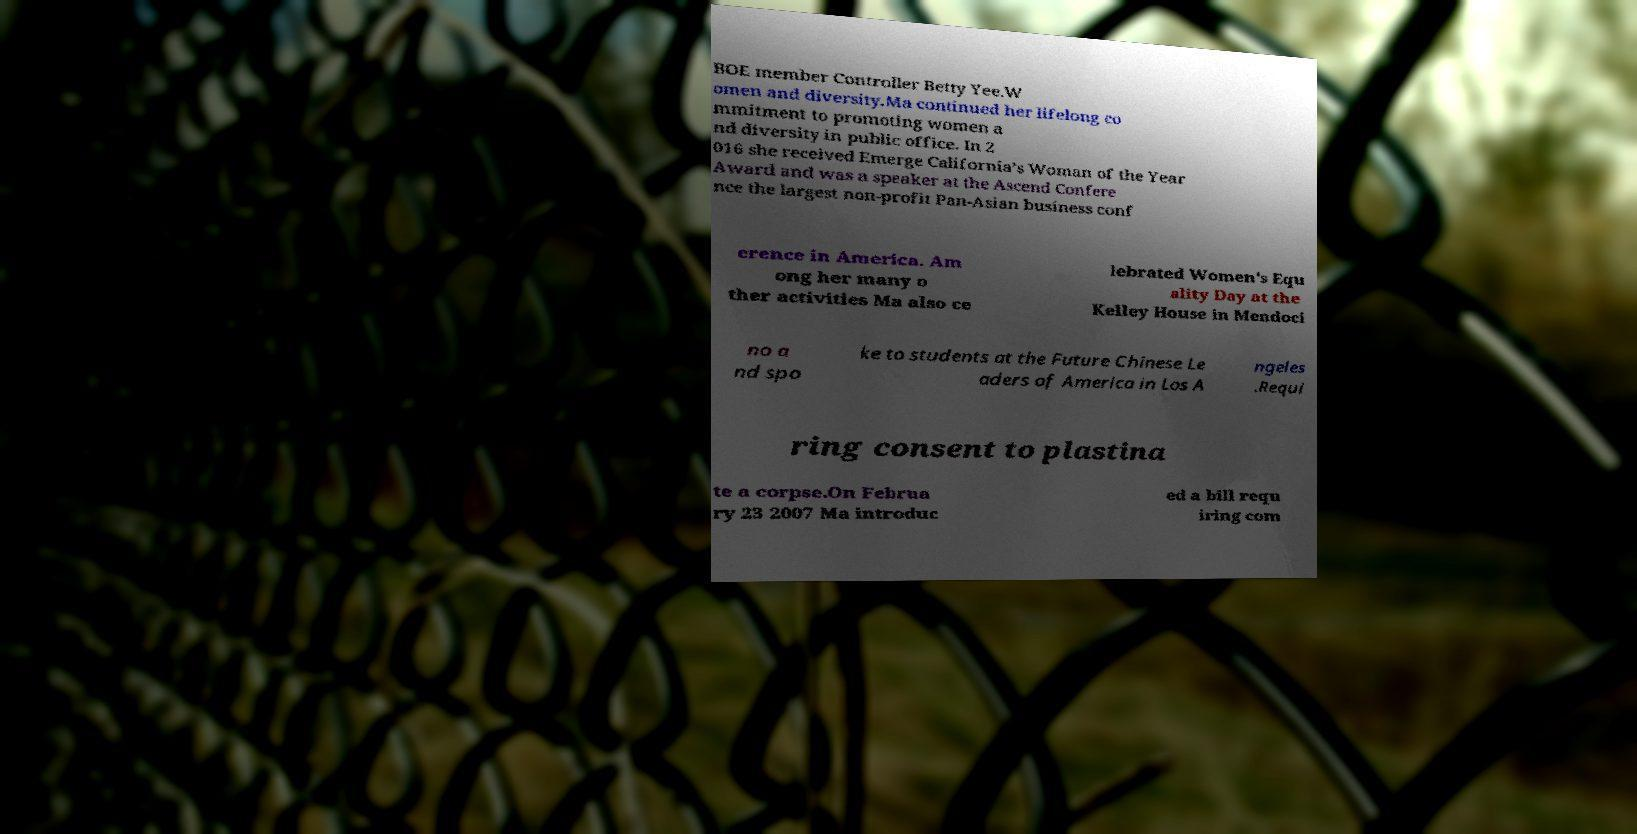For documentation purposes, I need the text within this image transcribed. Could you provide that? BOE member Controller Betty Yee.W omen and diversity.Ma continued her lifelong co mmitment to promoting women a nd diversity in public office. In 2 016 she received Emerge California’s Woman of the Year Award and was a speaker at the Ascend Confere nce the largest non-profit Pan-Asian business conf erence in America. Am ong her many o ther activities Ma also ce lebrated Women's Equ ality Day at the Kelley House in Mendoci no a nd spo ke to students at the Future Chinese Le aders of America in Los A ngeles .Requi ring consent to plastina te a corpse.On Februa ry 23 2007 Ma introduc ed a bill requ iring com 